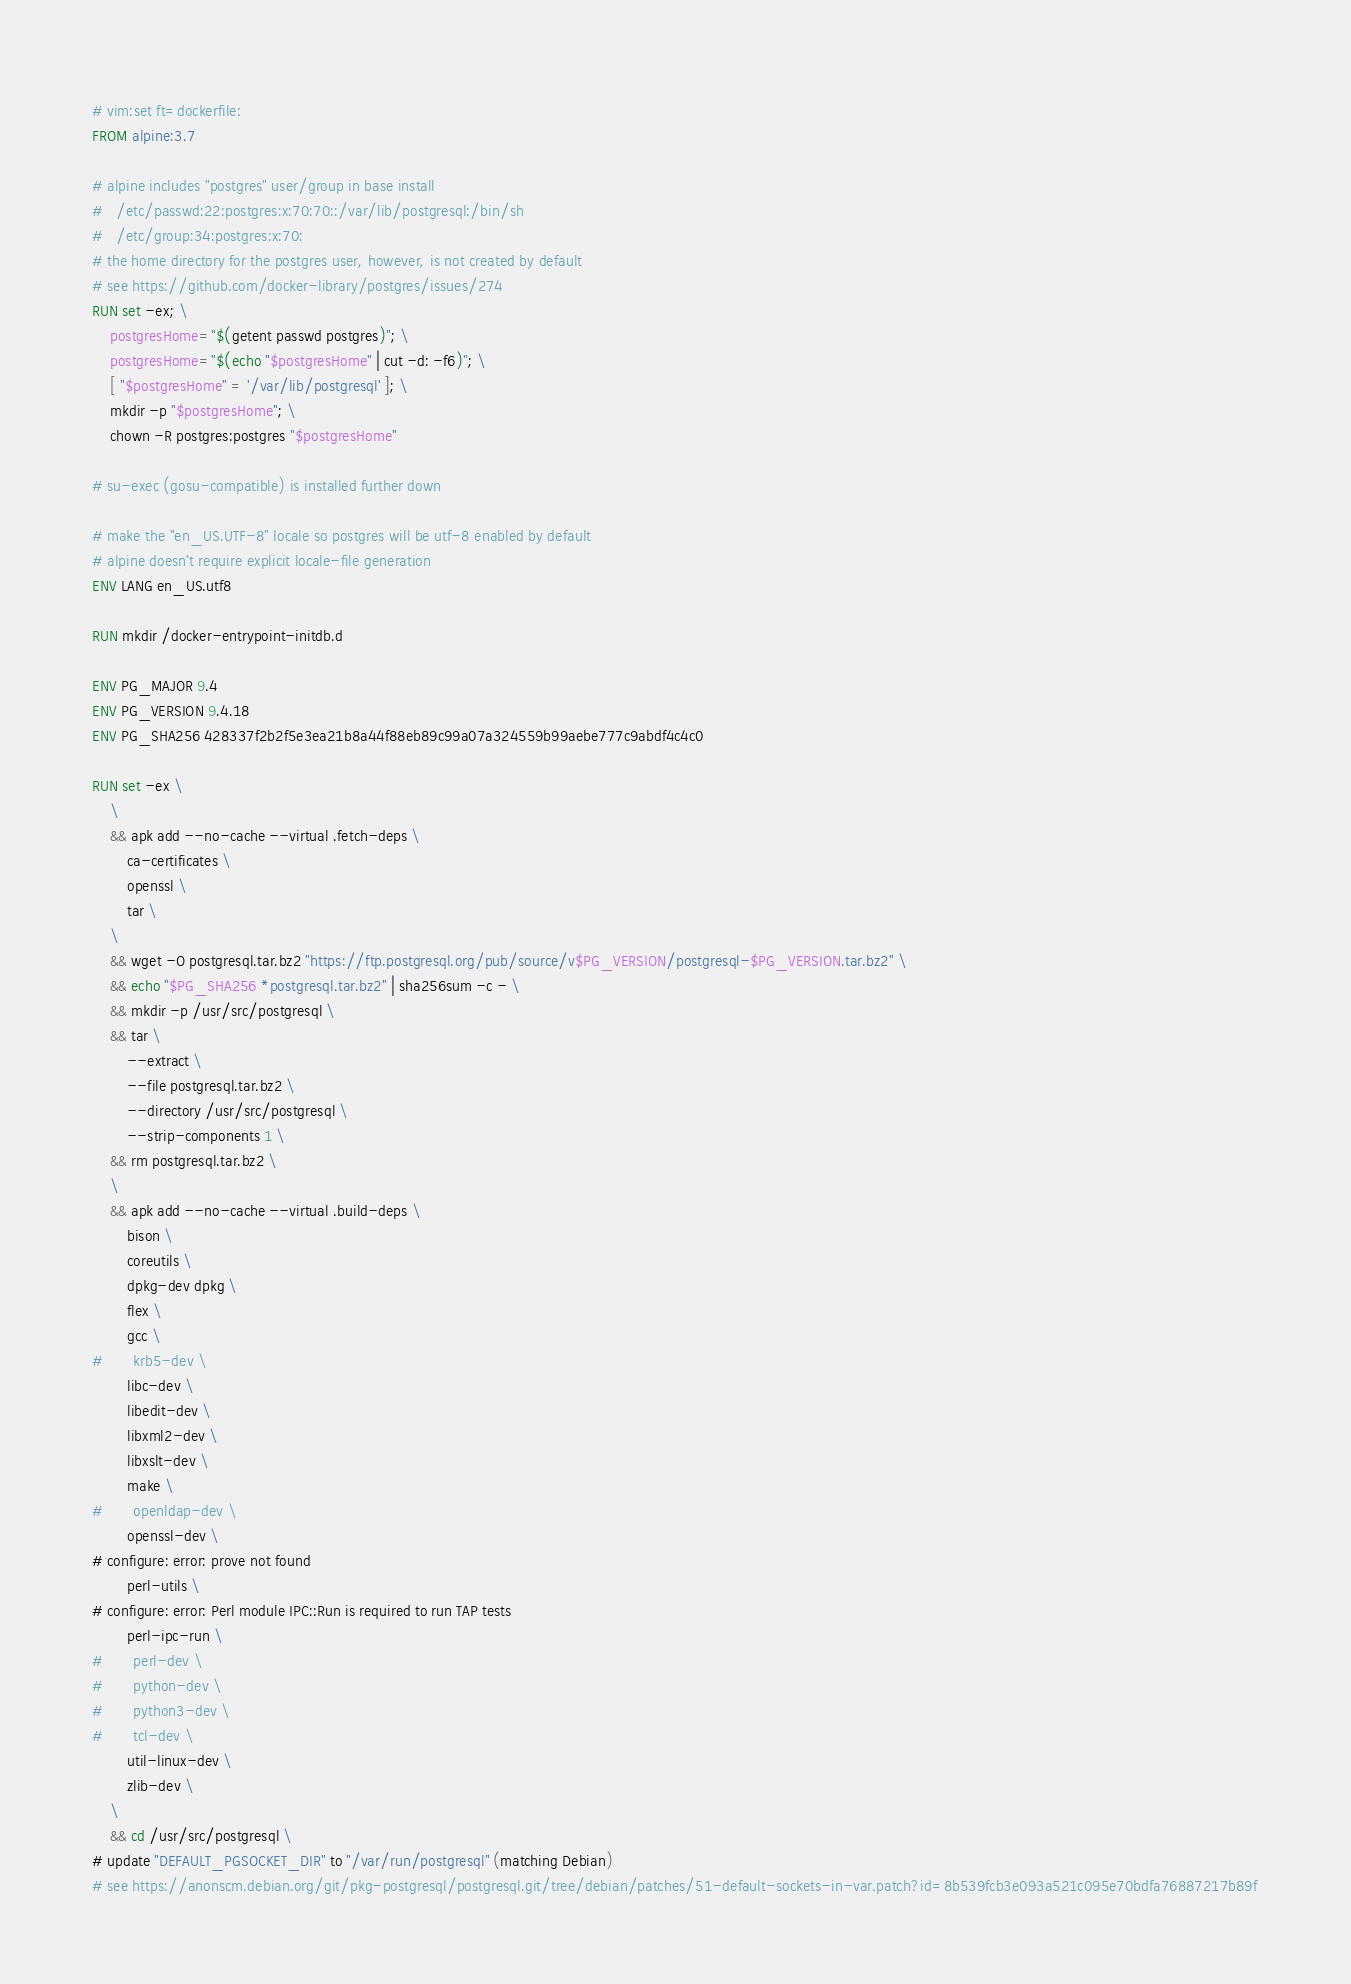Convert code to text. <code><loc_0><loc_0><loc_500><loc_500><_Dockerfile_># vim:set ft=dockerfile:
FROM alpine:3.7

# alpine includes "postgres" user/group in base install
#   /etc/passwd:22:postgres:x:70:70::/var/lib/postgresql:/bin/sh
#   /etc/group:34:postgres:x:70:
# the home directory for the postgres user, however, is not created by default
# see https://github.com/docker-library/postgres/issues/274
RUN set -ex; \
	postgresHome="$(getent passwd postgres)"; \
	postgresHome="$(echo "$postgresHome" | cut -d: -f6)"; \
	[ "$postgresHome" = '/var/lib/postgresql' ]; \
	mkdir -p "$postgresHome"; \
	chown -R postgres:postgres "$postgresHome"

# su-exec (gosu-compatible) is installed further down

# make the "en_US.UTF-8" locale so postgres will be utf-8 enabled by default
# alpine doesn't require explicit locale-file generation
ENV LANG en_US.utf8

RUN mkdir /docker-entrypoint-initdb.d

ENV PG_MAJOR 9.4
ENV PG_VERSION 9.4.18
ENV PG_SHA256 428337f2b2f5e3ea21b8a44f88eb89c99a07a324559b99aebe777c9abdf4c4c0

RUN set -ex \
	\
	&& apk add --no-cache --virtual .fetch-deps \
		ca-certificates \
		openssl \
		tar \
	\
	&& wget -O postgresql.tar.bz2 "https://ftp.postgresql.org/pub/source/v$PG_VERSION/postgresql-$PG_VERSION.tar.bz2" \
	&& echo "$PG_SHA256 *postgresql.tar.bz2" | sha256sum -c - \
	&& mkdir -p /usr/src/postgresql \
	&& tar \
		--extract \
		--file postgresql.tar.bz2 \
		--directory /usr/src/postgresql \
		--strip-components 1 \
	&& rm postgresql.tar.bz2 \
	\
	&& apk add --no-cache --virtual .build-deps \
		bison \
		coreutils \
		dpkg-dev dpkg \
		flex \
		gcc \
#		krb5-dev \
		libc-dev \
		libedit-dev \
		libxml2-dev \
		libxslt-dev \
		make \
#		openldap-dev \
		openssl-dev \
# configure: error: prove not found
		perl-utils \
# configure: error: Perl module IPC::Run is required to run TAP tests
		perl-ipc-run \
#		perl-dev \
#		python-dev \
#		python3-dev \
#		tcl-dev \
		util-linux-dev \
		zlib-dev \
	\
	&& cd /usr/src/postgresql \
# update "DEFAULT_PGSOCKET_DIR" to "/var/run/postgresql" (matching Debian)
# see https://anonscm.debian.org/git/pkg-postgresql/postgresql.git/tree/debian/patches/51-default-sockets-in-var.patch?id=8b539fcb3e093a521c095e70bdfa76887217b89f</code> 